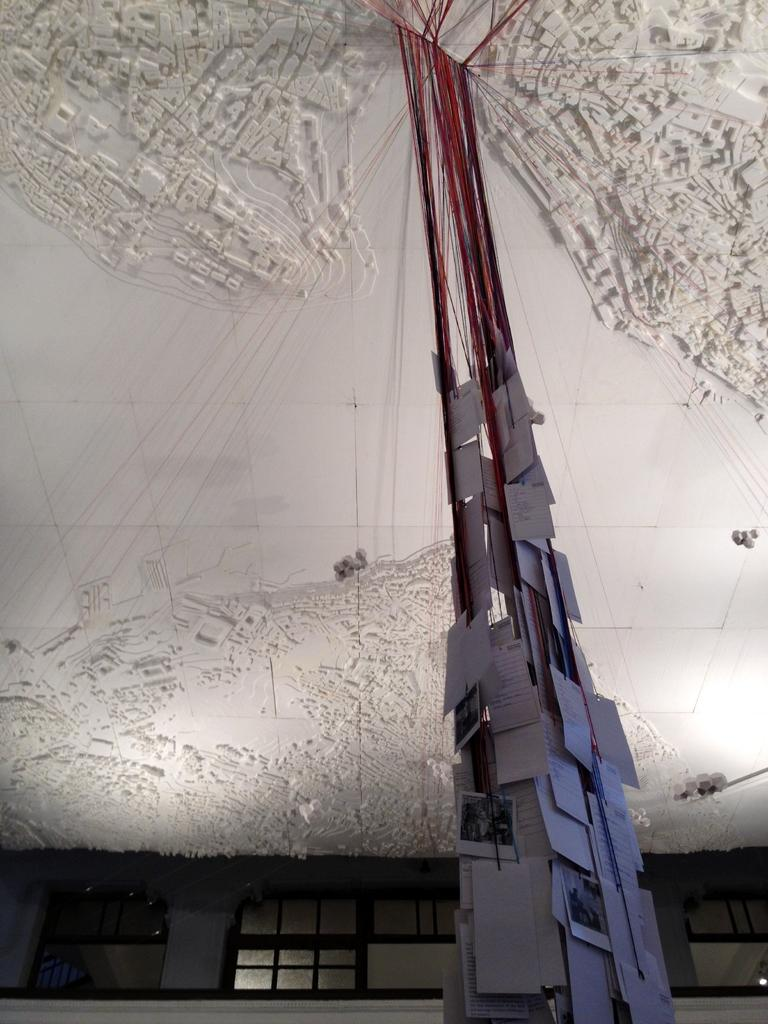What type of items can be seen in the image? There are photos, papers, and threads in the image. What part of the room can be seen in the image? The ceiling is visible in the image. What is present in the background of the image? There are windows in the background of the image. Can you describe the objects in the image? There are objects in the image, but their specific nature is not mentioned in the facts. What type of marble can be seen on the floor in the image? There is no mention of marble in the image; the facts only mention photos, papers, threads, the ceiling, and windows in the background. 